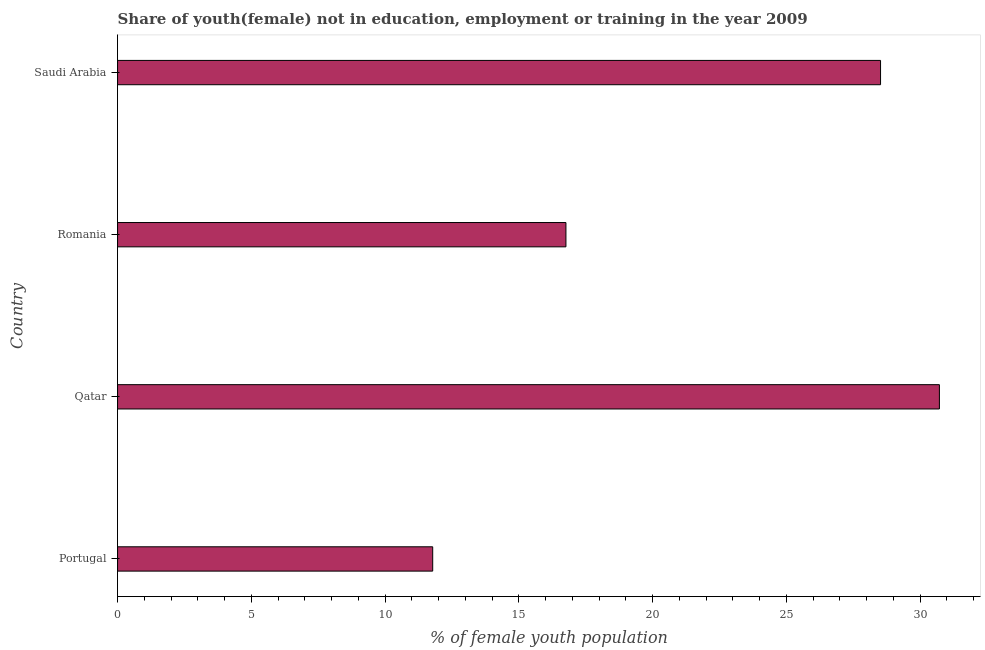Does the graph contain any zero values?
Your response must be concise. No. Does the graph contain grids?
Provide a short and direct response. No. What is the title of the graph?
Provide a short and direct response. Share of youth(female) not in education, employment or training in the year 2009. What is the label or title of the X-axis?
Give a very brief answer. % of female youth population. What is the unemployed female youth population in Qatar?
Offer a terse response. 30.72. Across all countries, what is the maximum unemployed female youth population?
Give a very brief answer. 30.72. Across all countries, what is the minimum unemployed female youth population?
Offer a very short reply. 11.78. In which country was the unemployed female youth population maximum?
Ensure brevity in your answer.  Qatar. In which country was the unemployed female youth population minimum?
Your answer should be compact. Portugal. What is the sum of the unemployed female youth population?
Give a very brief answer. 87.78. What is the difference between the unemployed female youth population in Qatar and Romania?
Keep it short and to the point. 13.96. What is the average unemployed female youth population per country?
Keep it short and to the point. 21.95. What is the median unemployed female youth population?
Offer a very short reply. 22.64. In how many countries, is the unemployed female youth population greater than 14 %?
Provide a succinct answer. 3. What is the ratio of the unemployed female youth population in Portugal to that in Saudi Arabia?
Provide a succinct answer. 0.41. Is the difference between the unemployed female youth population in Qatar and Romania greater than the difference between any two countries?
Ensure brevity in your answer.  No. What is the difference between the highest and the second highest unemployed female youth population?
Provide a short and direct response. 2.2. Is the sum of the unemployed female youth population in Romania and Saudi Arabia greater than the maximum unemployed female youth population across all countries?
Your answer should be very brief. Yes. What is the difference between the highest and the lowest unemployed female youth population?
Give a very brief answer. 18.94. What is the % of female youth population in Portugal?
Offer a terse response. 11.78. What is the % of female youth population in Qatar?
Provide a succinct answer. 30.72. What is the % of female youth population of Romania?
Ensure brevity in your answer.  16.76. What is the % of female youth population in Saudi Arabia?
Offer a terse response. 28.52. What is the difference between the % of female youth population in Portugal and Qatar?
Your response must be concise. -18.94. What is the difference between the % of female youth population in Portugal and Romania?
Keep it short and to the point. -4.98. What is the difference between the % of female youth population in Portugal and Saudi Arabia?
Your response must be concise. -16.74. What is the difference between the % of female youth population in Qatar and Romania?
Give a very brief answer. 13.96. What is the difference between the % of female youth population in Romania and Saudi Arabia?
Give a very brief answer. -11.76. What is the ratio of the % of female youth population in Portugal to that in Qatar?
Provide a succinct answer. 0.38. What is the ratio of the % of female youth population in Portugal to that in Romania?
Your answer should be very brief. 0.7. What is the ratio of the % of female youth population in Portugal to that in Saudi Arabia?
Your response must be concise. 0.41. What is the ratio of the % of female youth population in Qatar to that in Romania?
Give a very brief answer. 1.83. What is the ratio of the % of female youth population in Qatar to that in Saudi Arabia?
Ensure brevity in your answer.  1.08. What is the ratio of the % of female youth population in Romania to that in Saudi Arabia?
Ensure brevity in your answer.  0.59. 